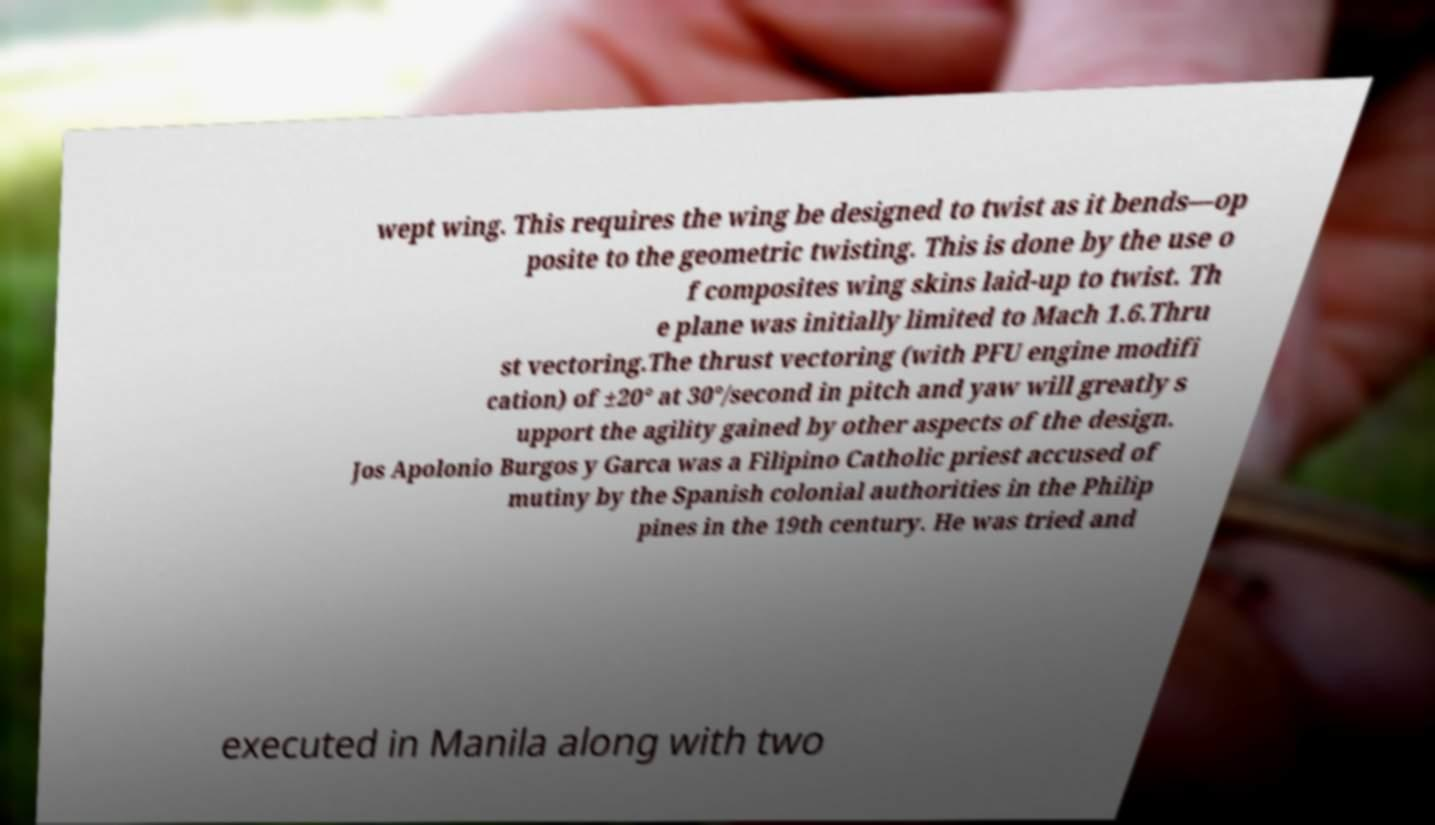What messages or text are displayed in this image? I need them in a readable, typed format. wept wing. This requires the wing be designed to twist as it bends—op posite to the geometric twisting. This is done by the use o f composites wing skins laid-up to twist. Th e plane was initially limited to Mach 1.6.Thru st vectoring.The thrust vectoring (with PFU engine modifi cation) of ±20° at 30°/second in pitch and yaw will greatly s upport the agility gained by other aspects of the design. Jos Apolonio Burgos y Garca was a Filipino Catholic priest accused of mutiny by the Spanish colonial authorities in the Philip pines in the 19th century. He was tried and executed in Manila along with two 